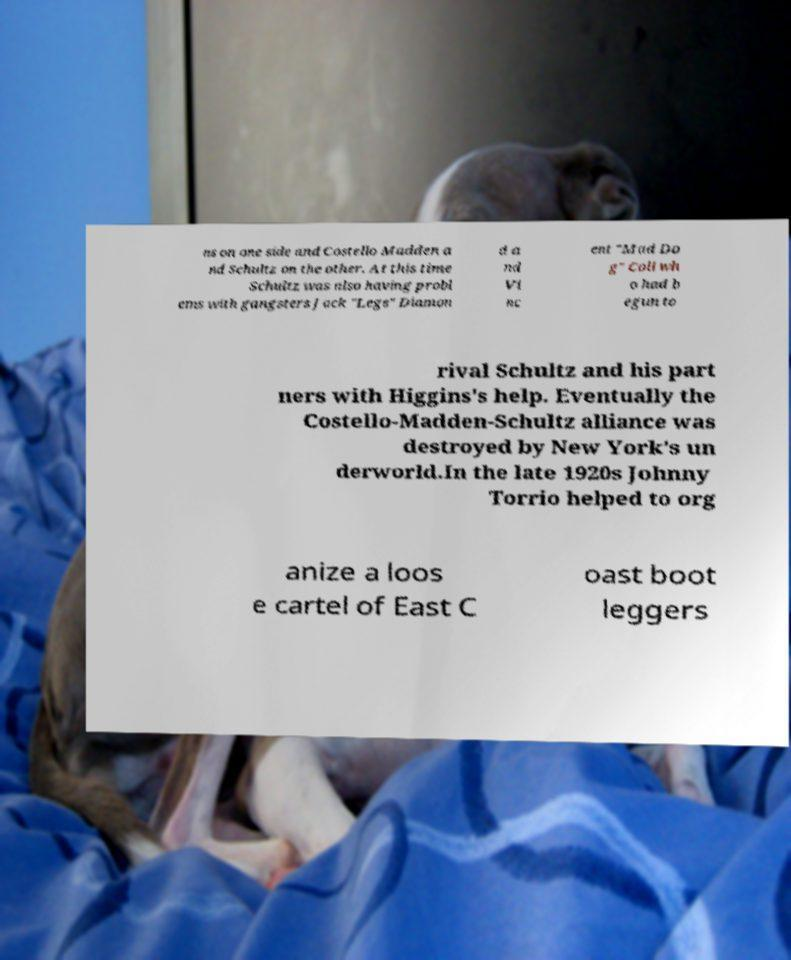Can you accurately transcribe the text from the provided image for me? ns on one side and Costello Madden a nd Schultz on the other. At this time Schultz was also having probl ems with gangsters Jack "Legs" Diamon d a nd Vi nc ent "Mad Do g" Coll wh o had b egun to rival Schultz and his part ners with Higgins's help. Eventually the Costello-Madden-Schultz alliance was destroyed by New York's un derworld.In the late 1920s Johnny Torrio helped to org anize a loos e cartel of East C oast boot leggers 